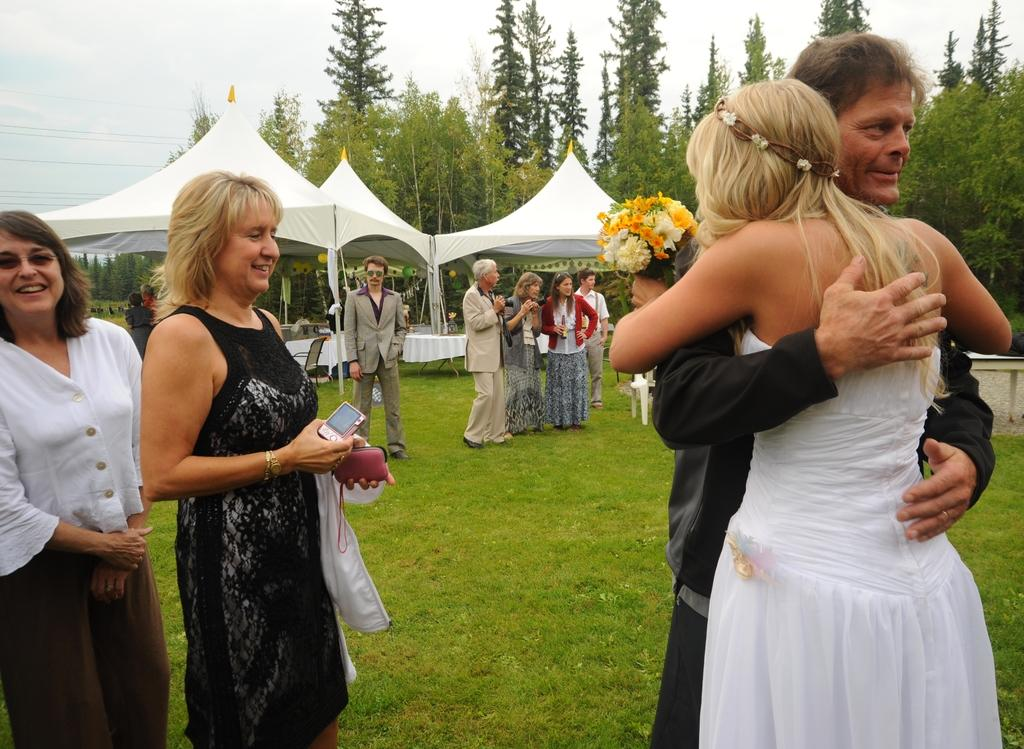What are the people in the image standing on? The people in the image are standing on the grass. What can be seen in the image besides the people? There is a flower bouquet, a camera, chairs, tents, tables, trees, and the sky visible in the image. What type of event might be taking place based on the presence of chairs, tents, and tables? The presence of chairs, tents, and tables suggests that an outdoor event or gathering might be taking place. What type of pain is being experienced by the person holding the camera in the image? There is no indication of pain being experienced by anyone in the image, and the presence of a camera does not suggest any pain-related activity. 